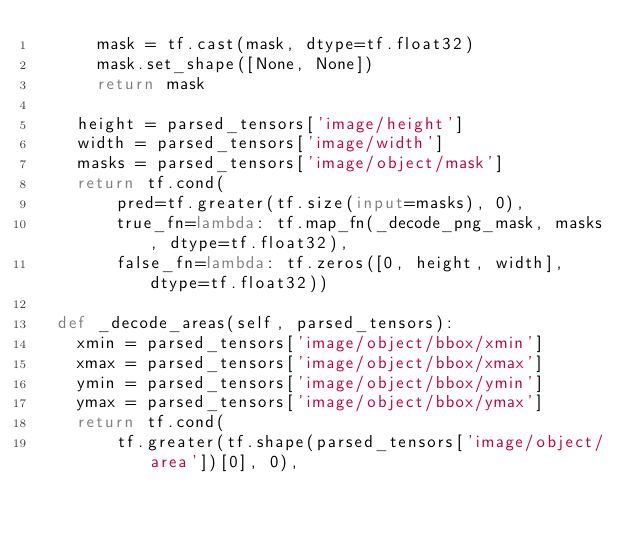Convert code to text. <code><loc_0><loc_0><loc_500><loc_500><_Python_>      mask = tf.cast(mask, dtype=tf.float32)
      mask.set_shape([None, None])
      return mask

    height = parsed_tensors['image/height']
    width = parsed_tensors['image/width']
    masks = parsed_tensors['image/object/mask']
    return tf.cond(
        pred=tf.greater(tf.size(input=masks), 0),
        true_fn=lambda: tf.map_fn(_decode_png_mask, masks, dtype=tf.float32),
        false_fn=lambda: tf.zeros([0, height, width], dtype=tf.float32))

  def _decode_areas(self, parsed_tensors):
    xmin = parsed_tensors['image/object/bbox/xmin']
    xmax = parsed_tensors['image/object/bbox/xmax']
    ymin = parsed_tensors['image/object/bbox/ymin']
    ymax = parsed_tensors['image/object/bbox/ymax']
    return tf.cond(
        tf.greater(tf.shape(parsed_tensors['image/object/area'])[0], 0),</code> 